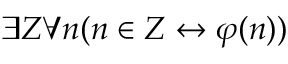<formula> <loc_0><loc_0><loc_500><loc_500>\exists Z \forall n ( n \in Z \leftrightarrow \varphi ( n ) )</formula> 